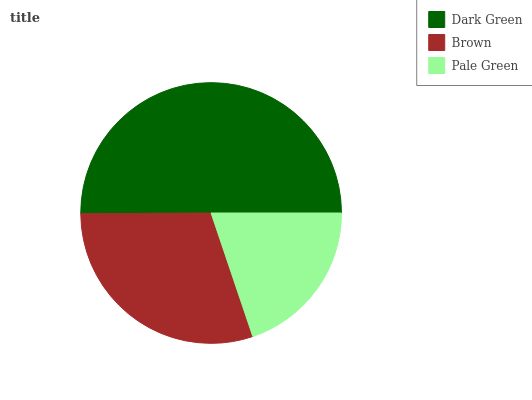Is Pale Green the minimum?
Answer yes or no. Yes. Is Dark Green the maximum?
Answer yes or no. Yes. Is Brown the minimum?
Answer yes or no. No. Is Brown the maximum?
Answer yes or no. No. Is Dark Green greater than Brown?
Answer yes or no. Yes. Is Brown less than Dark Green?
Answer yes or no. Yes. Is Brown greater than Dark Green?
Answer yes or no. No. Is Dark Green less than Brown?
Answer yes or no. No. Is Brown the high median?
Answer yes or no. Yes. Is Brown the low median?
Answer yes or no. Yes. Is Pale Green the high median?
Answer yes or no. No. Is Dark Green the low median?
Answer yes or no. No. 